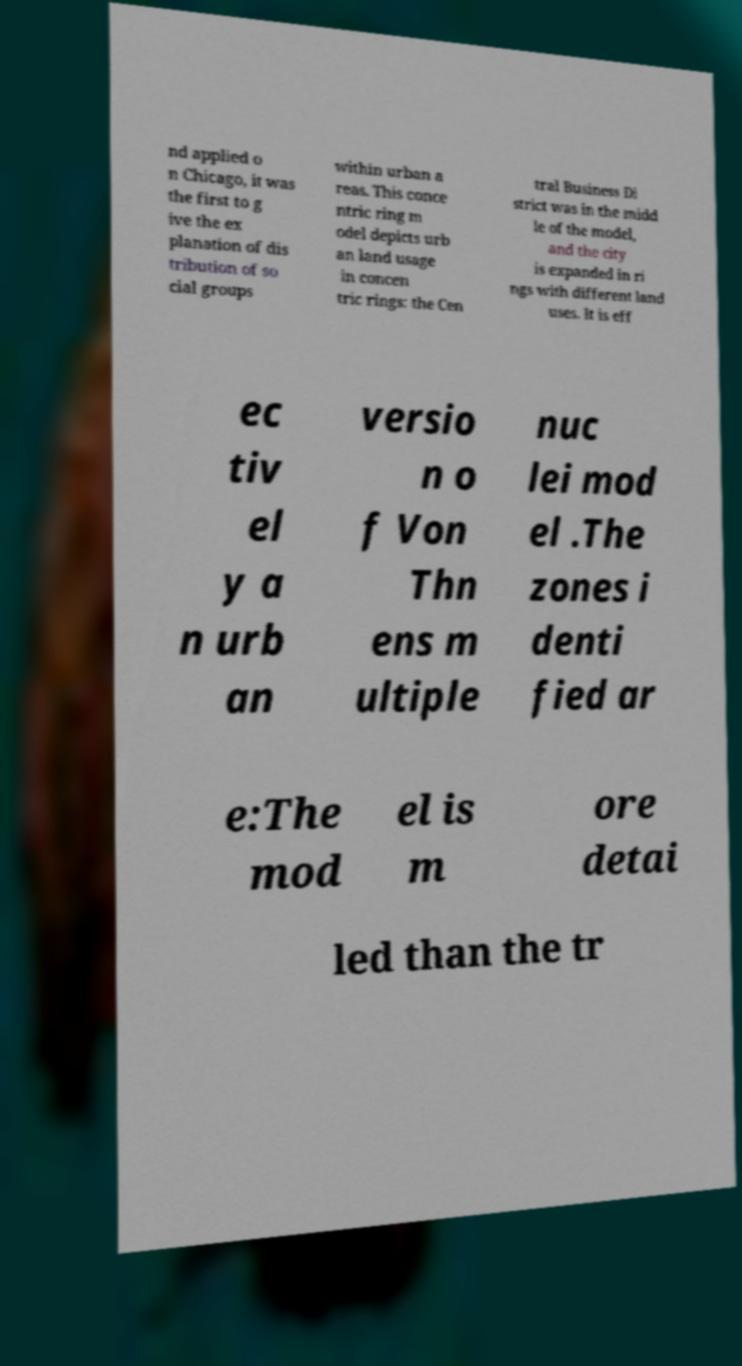I need the written content from this picture converted into text. Can you do that? nd applied o n Chicago, it was the first to g ive the ex planation of dis tribution of so cial groups within urban a reas. This conce ntric ring m odel depicts urb an land usage in concen tric rings: the Cen tral Business Di strict was in the midd le of the model, and the city is expanded in ri ngs with different land uses. It is eff ec tiv el y a n urb an versio n o f Von Thn ens m ultiple nuc lei mod el .The zones i denti fied ar e:The mod el is m ore detai led than the tr 